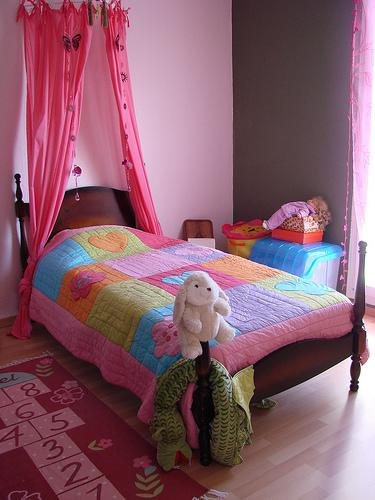Question: what is the color of the net?
Choices:
A. Pink.
B. Orange.
C. Red.
D. Blue.
Answer with the letter. Answer: A 